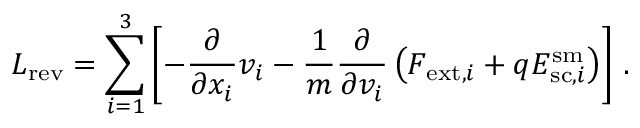<formula> <loc_0><loc_0><loc_500><loc_500>L _ { r e v } = \sum _ { i = 1 } ^ { 3 } \left [ - \frac { \partial } { \partial x _ { i } } v _ { i } - \frac { 1 } { m } \frac { \partial } { \partial v _ { i } } \left ( F _ { e x t , i } + q E _ { s c , i } ^ { s m } \right ) \right ] \, .</formula> 